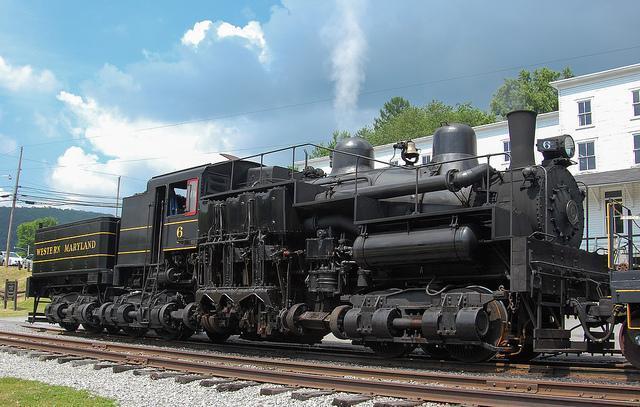How many cars does the train have?
Give a very brief answer. 1. 